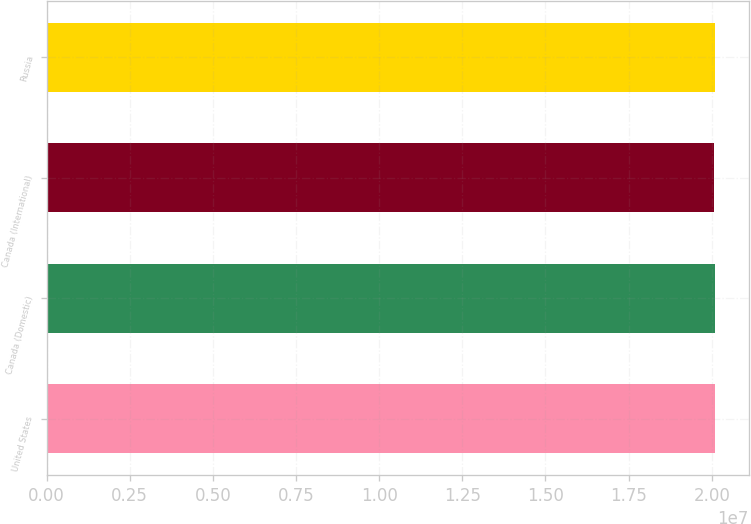Convert chart. <chart><loc_0><loc_0><loc_500><loc_500><bar_chart><fcel>United States<fcel>Canada (Domestic)<fcel>Canada (International)<fcel>Russia<nl><fcel>2.0102e+07<fcel>2.0092e+07<fcel>2.0082e+07<fcel>2.0094e+07<nl></chart> 